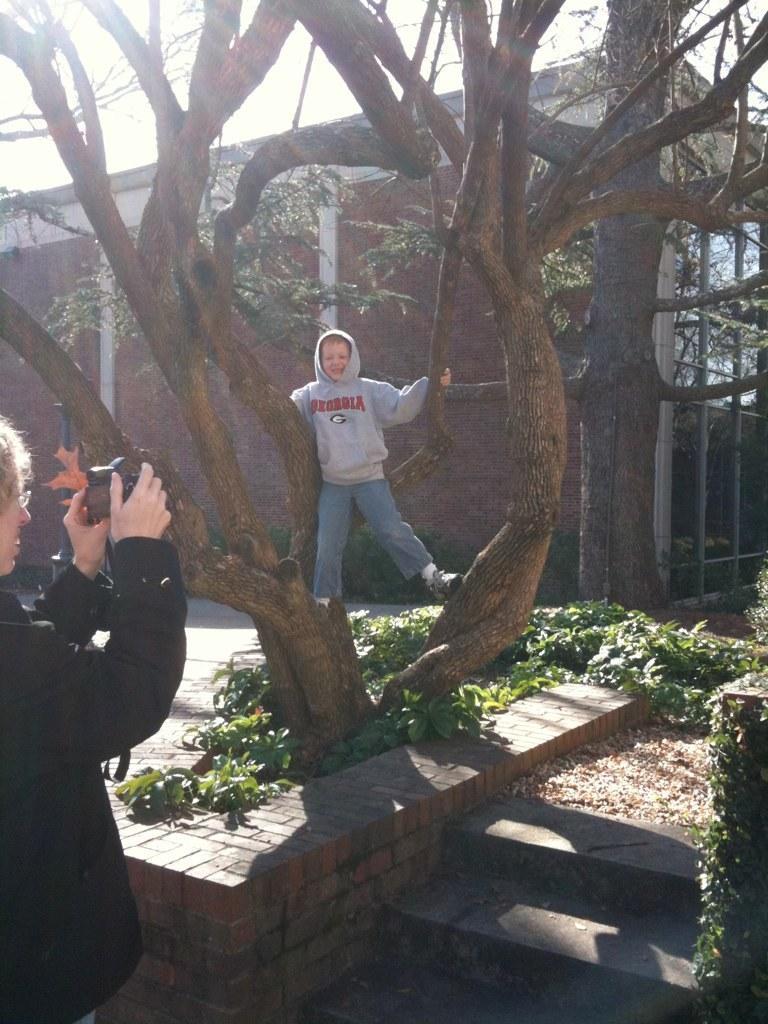Please provide a concise description of this image. In the picture there is a boy standing on the tree trunk and in front of the boy a woman is standing and capturing his picture, around the tree there are small bushes and in the background there is a building and there are two trees in front of the building and there is a bright sunlight falling on the surface. 